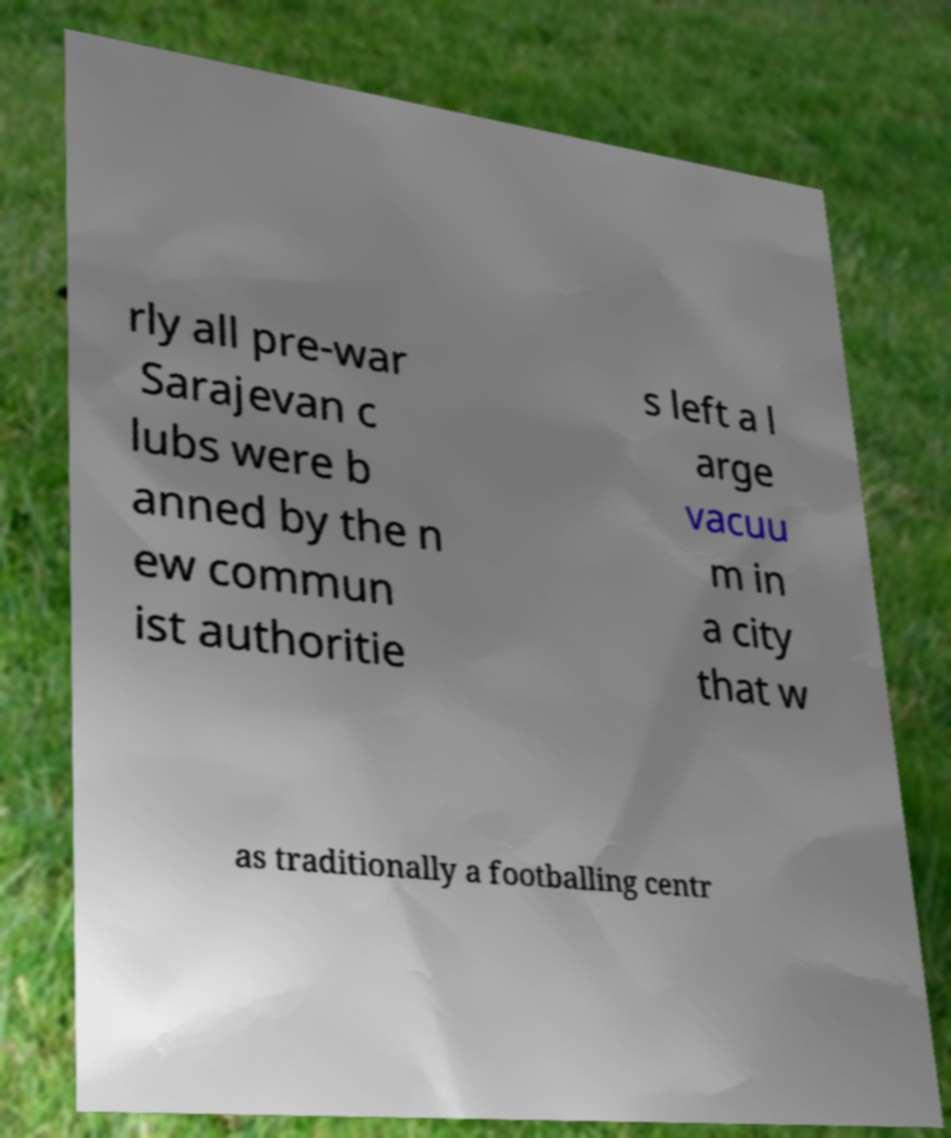Please read and relay the text visible in this image. What does it say? rly all pre-war Sarajevan c lubs were b anned by the n ew commun ist authoritie s left a l arge vacuu m in a city that w as traditionally a footballing centr 